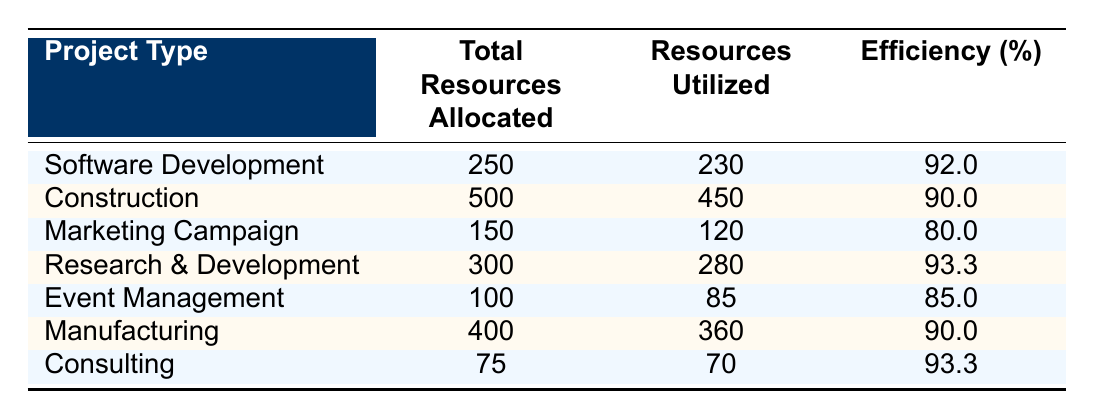What is the efficiency percentage of the Marketing Campaign project? The table indicates that the efficiency percentage for the Marketing Campaign is explicitly listed as 80.0.
Answer: 80.0 Which project type had the highest resource allocation? By examining the "Total Resources Allocated" column, the Construction project, with 500 resources, has the highest allocation.
Answer: Construction What is the total resources utilized across all projects? To find the total resources utilized, I will sum up each project's utilized resources: (230 + 450 + 120 + 280 + 85 + 360 + 70) = 1595.
Answer: 1595 Is the efficiency of Consulting greater than the efficiency of Event Management? Consulting has an efficiency percentage of 93.3, while Event Management has 85.0. Since 93.3 is greater than 85.0, the answer is yes.
Answer: Yes What is the difference in efficiency between Research & Development and Manufacturing? The efficiency of Research & Development is 93.3 and that of Manufacturing is 90.0. The difference is calculated as 93.3 - 90.0 = 3.3.
Answer: 3.3 What is the average efficiency percentage of all project types? To calculate the average efficiency, sum all the efficiency percentages: (92.0 + 90.0 + 80.0 + 93.3 + 85.0 + 90.0 + 93.3) = 519.6; then divide by the number of project types (7): 519.6 / 7 ≈ 74.2.
Answer: 74.2 Is the total resources utilized for Software Development more than that of Event Management? Software Development utilized 230 resources whereas Event Management utilized 85 resources. Since 230 is greater than 85, the answer is yes.
Answer: Yes What project type has the least efficiency percentage among those listed? The project with the least efficiency percentage is the Marketing Campaign at 80.0, as it has the lowest value when comparing all efficiencies.
Answer: Marketing Campaign What is the combined total of resources allocated to Research & Development and Consulting? The total resources allocated to Research & Development is 300 and to Consulting is 75. The combined total is 300 + 75 = 375.
Answer: 375 